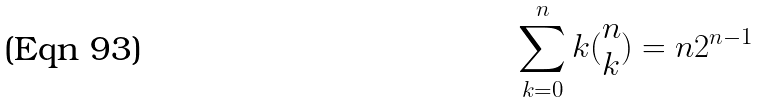<formula> <loc_0><loc_0><loc_500><loc_500>\sum _ { k = 0 } ^ { n } k ( \begin{matrix} n \\ k \end{matrix} ) = n 2 ^ { n - 1 }</formula> 